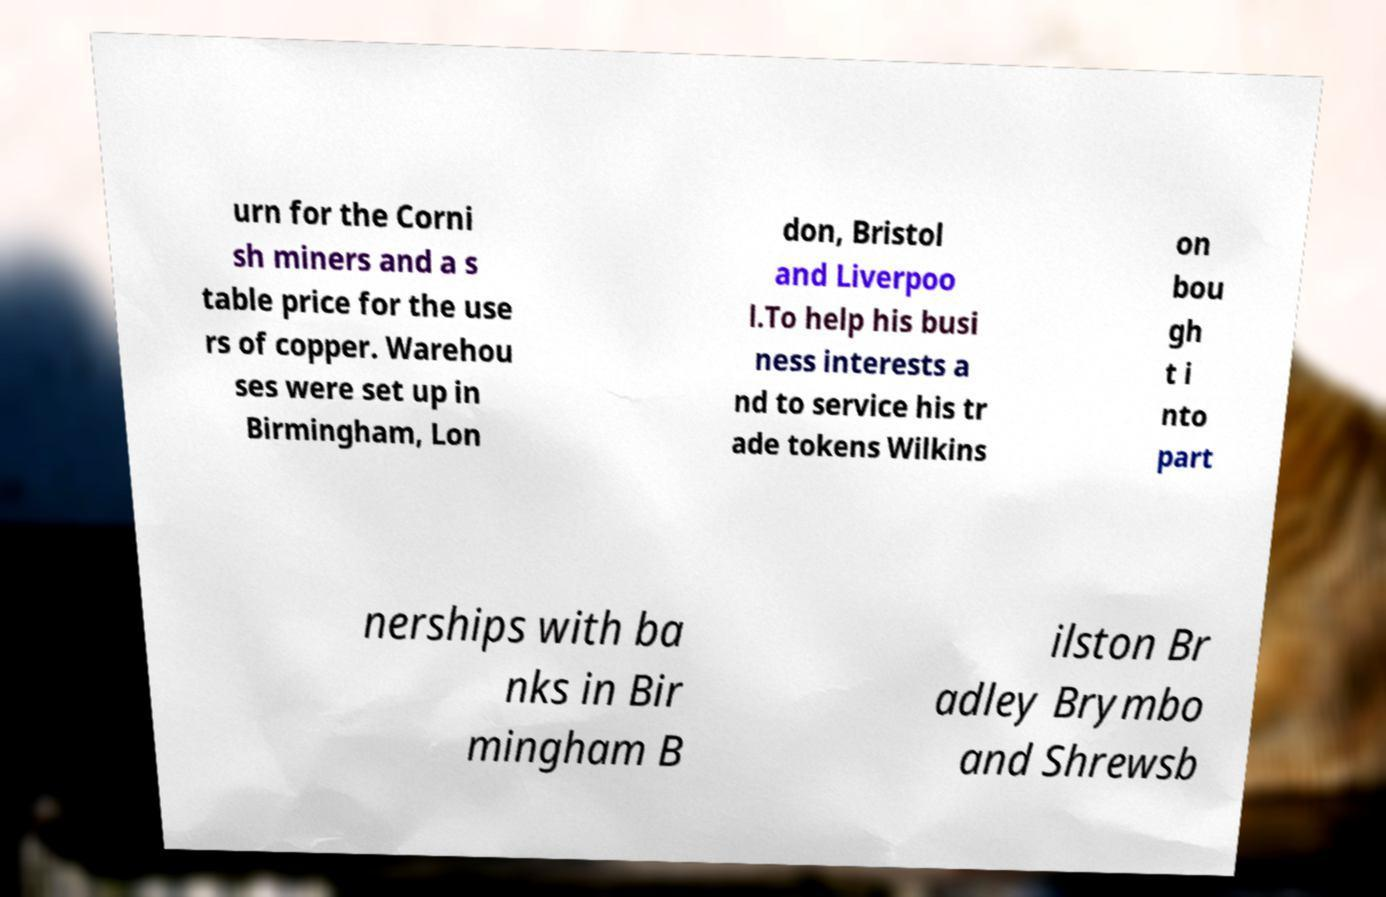I need the written content from this picture converted into text. Can you do that? urn for the Corni sh miners and a s table price for the use rs of copper. Warehou ses were set up in Birmingham, Lon don, Bristol and Liverpoo l.To help his busi ness interests a nd to service his tr ade tokens Wilkins on bou gh t i nto part nerships with ba nks in Bir mingham B ilston Br adley Brymbo and Shrewsb 